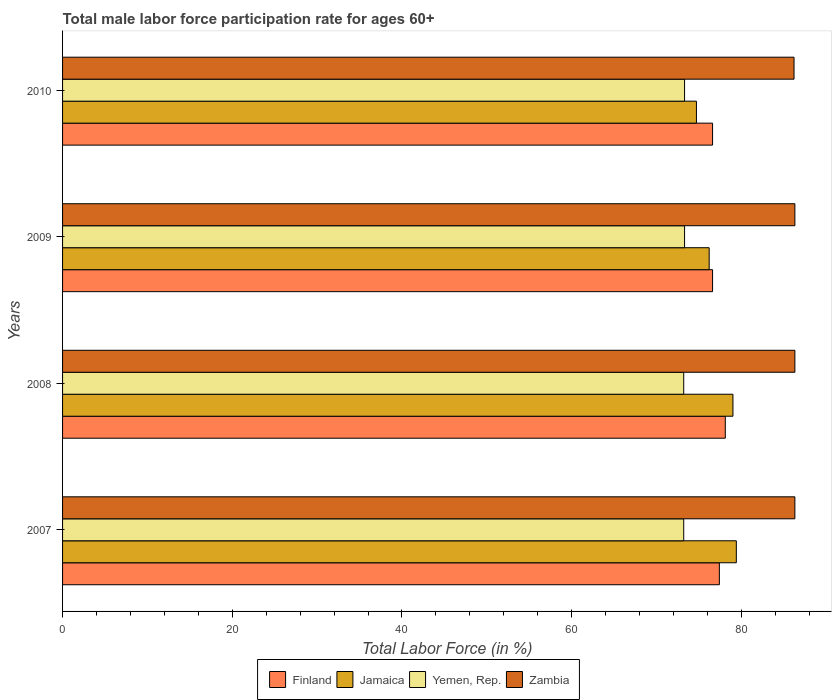How many groups of bars are there?
Offer a terse response. 4. How many bars are there on the 3rd tick from the bottom?
Provide a succinct answer. 4. In how many cases, is the number of bars for a given year not equal to the number of legend labels?
Your answer should be very brief. 0. What is the male labor force participation rate in Jamaica in 2010?
Your response must be concise. 74.7. Across all years, what is the maximum male labor force participation rate in Finland?
Ensure brevity in your answer.  78.1. Across all years, what is the minimum male labor force participation rate in Finland?
Make the answer very short. 76.6. What is the total male labor force participation rate in Finland in the graph?
Ensure brevity in your answer.  308.7. What is the difference between the male labor force participation rate in Jamaica in 2010 and the male labor force participation rate in Zambia in 2008?
Provide a succinct answer. -11.6. What is the average male labor force participation rate in Finland per year?
Provide a succinct answer. 77.17. In the year 2008, what is the difference between the male labor force participation rate in Finland and male labor force participation rate in Zambia?
Make the answer very short. -8.2. In how many years, is the male labor force participation rate in Jamaica greater than 80 %?
Provide a short and direct response. 0. What is the ratio of the male labor force participation rate in Finland in 2007 to that in 2009?
Provide a succinct answer. 1.01. Is the male labor force participation rate in Zambia in 2009 less than that in 2010?
Offer a terse response. No. What is the difference between the highest and the second highest male labor force participation rate in Zambia?
Your answer should be compact. 0. What is the difference between the highest and the lowest male labor force participation rate in Yemen, Rep.?
Make the answer very short. 0.1. Is the sum of the male labor force participation rate in Finland in 2008 and 2009 greater than the maximum male labor force participation rate in Jamaica across all years?
Keep it short and to the point. Yes. What does the 4th bar from the top in 2009 represents?
Your response must be concise. Finland. What does the 4th bar from the bottom in 2009 represents?
Make the answer very short. Zambia. How many bars are there?
Keep it short and to the point. 16. Are all the bars in the graph horizontal?
Provide a succinct answer. Yes. Does the graph contain any zero values?
Your response must be concise. No. What is the title of the graph?
Provide a succinct answer. Total male labor force participation rate for ages 60+. Does "Kuwait" appear as one of the legend labels in the graph?
Make the answer very short. No. What is the label or title of the Y-axis?
Offer a terse response. Years. What is the Total Labor Force (in %) in Finland in 2007?
Your response must be concise. 77.4. What is the Total Labor Force (in %) of Jamaica in 2007?
Your answer should be very brief. 79.4. What is the Total Labor Force (in %) in Yemen, Rep. in 2007?
Keep it short and to the point. 73.2. What is the Total Labor Force (in %) in Zambia in 2007?
Give a very brief answer. 86.3. What is the Total Labor Force (in %) of Finland in 2008?
Ensure brevity in your answer.  78.1. What is the Total Labor Force (in %) of Jamaica in 2008?
Make the answer very short. 79. What is the Total Labor Force (in %) in Yemen, Rep. in 2008?
Give a very brief answer. 73.2. What is the Total Labor Force (in %) in Zambia in 2008?
Offer a very short reply. 86.3. What is the Total Labor Force (in %) of Finland in 2009?
Offer a very short reply. 76.6. What is the Total Labor Force (in %) of Jamaica in 2009?
Give a very brief answer. 76.2. What is the Total Labor Force (in %) in Yemen, Rep. in 2009?
Make the answer very short. 73.3. What is the Total Labor Force (in %) of Zambia in 2009?
Your answer should be very brief. 86.3. What is the Total Labor Force (in %) of Finland in 2010?
Provide a short and direct response. 76.6. What is the Total Labor Force (in %) of Jamaica in 2010?
Keep it short and to the point. 74.7. What is the Total Labor Force (in %) of Yemen, Rep. in 2010?
Offer a very short reply. 73.3. What is the Total Labor Force (in %) of Zambia in 2010?
Your answer should be very brief. 86.2. Across all years, what is the maximum Total Labor Force (in %) in Finland?
Ensure brevity in your answer.  78.1. Across all years, what is the maximum Total Labor Force (in %) in Jamaica?
Ensure brevity in your answer.  79.4. Across all years, what is the maximum Total Labor Force (in %) of Yemen, Rep.?
Make the answer very short. 73.3. Across all years, what is the maximum Total Labor Force (in %) in Zambia?
Your answer should be very brief. 86.3. Across all years, what is the minimum Total Labor Force (in %) in Finland?
Give a very brief answer. 76.6. Across all years, what is the minimum Total Labor Force (in %) of Jamaica?
Your answer should be compact. 74.7. Across all years, what is the minimum Total Labor Force (in %) of Yemen, Rep.?
Give a very brief answer. 73.2. Across all years, what is the minimum Total Labor Force (in %) in Zambia?
Ensure brevity in your answer.  86.2. What is the total Total Labor Force (in %) in Finland in the graph?
Your answer should be very brief. 308.7. What is the total Total Labor Force (in %) of Jamaica in the graph?
Give a very brief answer. 309.3. What is the total Total Labor Force (in %) in Yemen, Rep. in the graph?
Ensure brevity in your answer.  293. What is the total Total Labor Force (in %) in Zambia in the graph?
Give a very brief answer. 345.1. What is the difference between the Total Labor Force (in %) in Jamaica in 2007 and that in 2008?
Your answer should be compact. 0.4. What is the difference between the Total Labor Force (in %) in Jamaica in 2007 and that in 2009?
Your answer should be compact. 3.2. What is the difference between the Total Labor Force (in %) in Zambia in 2007 and that in 2009?
Provide a short and direct response. 0. What is the difference between the Total Labor Force (in %) of Jamaica in 2007 and that in 2010?
Provide a short and direct response. 4.7. What is the difference between the Total Labor Force (in %) in Yemen, Rep. in 2007 and that in 2010?
Ensure brevity in your answer.  -0.1. What is the difference between the Total Labor Force (in %) in Finland in 2008 and that in 2009?
Provide a succinct answer. 1.5. What is the difference between the Total Labor Force (in %) in Finland in 2008 and that in 2010?
Ensure brevity in your answer.  1.5. What is the difference between the Total Labor Force (in %) in Finland in 2009 and that in 2010?
Provide a succinct answer. 0. What is the difference between the Total Labor Force (in %) of Finland in 2007 and the Total Labor Force (in %) of Jamaica in 2009?
Make the answer very short. 1.2. What is the difference between the Total Labor Force (in %) of Jamaica in 2007 and the Total Labor Force (in %) of Yemen, Rep. in 2009?
Make the answer very short. 6.1. What is the difference between the Total Labor Force (in %) in Finland in 2007 and the Total Labor Force (in %) in Jamaica in 2010?
Your answer should be compact. 2.7. What is the difference between the Total Labor Force (in %) in Yemen, Rep. in 2007 and the Total Labor Force (in %) in Zambia in 2010?
Ensure brevity in your answer.  -13. What is the difference between the Total Labor Force (in %) in Finland in 2008 and the Total Labor Force (in %) in Jamaica in 2009?
Provide a succinct answer. 1.9. What is the difference between the Total Labor Force (in %) in Finland in 2008 and the Total Labor Force (in %) in Yemen, Rep. in 2009?
Your answer should be compact. 4.8. What is the difference between the Total Labor Force (in %) of Finland in 2008 and the Total Labor Force (in %) of Zambia in 2009?
Offer a very short reply. -8.2. What is the difference between the Total Labor Force (in %) of Jamaica in 2008 and the Total Labor Force (in %) of Yemen, Rep. in 2009?
Your answer should be very brief. 5.7. What is the difference between the Total Labor Force (in %) of Jamaica in 2008 and the Total Labor Force (in %) of Zambia in 2009?
Provide a succinct answer. -7.3. What is the difference between the Total Labor Force (in %) in Yemen, Rep. in 2008 and the Total Labor Force (in %) in Zambia in 2009?
Ensure brevity in your answer.  -13.1. What is the difference between the Total Labor Force (in %) of Finland in 2008 and the Total Labor Force (in %) of Yemen, Rep. in 2010?
Give a very brief answer. 4.8. What is the difference between the Total Labor Force (in %) of Finland in 2008 and the Total Labor Force (in %) of Zambia in 2010?
Your answer should be compact. -8.1. What is the difference between the Total Labor Force (in %) of Jamaica in 2008 and the Total Labor Force (in %) of Zambia in 2010?
Provide a short and direct response. -7.2. What is the difference between the Total Labor Force (in %) of Yemen, Rep. in 2008 and the Total Labor Force (in %) of Zambia in 2010?
Provide a short and direct response. -13. What is the difference between the Total Labor Force (in %) in Finland in 2009 and the Total Labor Force (in %) in Jamaica in 2010?
Your answer should be very brief. 1.9. What is the difference between the Total Labor Force (in %) in Finland in 2009 and the Total Labor Force (in %) in Yemen, Rep. in 2010?
Make the answer very short. 3.3. What is the difference between the Total Labor Force (in %) of Yemen, Rep. in 2009 and the Total Labor Force (in %) of Zambia in 2010?
Give a very brief answer. -12.9. What is the average Total Labor Force (in %) of Finland per year?
Your answer should be compact. 77.17. What is the average Total Labor Force (in %) of Jamaica per year?
Offer a terse response. 77.33. What is the average Total Labor Force (in %) of Yemen, Rep. per year?
Offer a very short reply. 73.25. What is the average Total Labor Force (in %) in Zambia per year?
Your answer should be compact. 86.28. In the year 2007, what is the difference between the Total Labor Force (in %) in Finland and Total Labor Force (in %) in Jamaica?
Give a very brief answer. -2. In the year 2007, what is the difference between the Total Labor Force (in %) in Finland and Total Labor Force (in %) in Yemen, Rep.?
Your answer should be very brief. 4.2. In the year 2007, what is the difference between the Total Labor Force (in %) of Finland and Total Labor Force (in %) of Zambia?
Give a very brief answer. -8.9. In the year 2007, what is the difference between the Total Labor Force (in %) in Jamaica and Total Labor Force (in %) in Zambia?
Offer a very short reply. -6.9. In the year 2007, what is the difference between the Total Labor Force (in %) in Yemen, Rep. and Total Labor Force (in %) in Zambia?
Make the answer very short. -13.1. In the year 2008, what is the difference between the Total Labor Force (in %) in Finland and Total Labor Force (in %) in Jamaica?
Ensure brevity in your answer.  -0.9. In the year 2008, what is the difference between the Total Labor Force (in %) in Finland and Total Labor Force (in %) in Yemen, Rep.?
Offer a very short reply. 4.9. In the year 2008, what is the difference between the Total Labor Force (in %) of Jamaica and Total Labor Force (in %) of Yemen, Rep.?
Provide a short and direct response. 5.8. In the year 2009, what is the difference between the Total Labor Force (in %) of Finland and Total Labor Force (in %) of Yemen, Rep.?
Provide a succinct answer. 3.3. In the year 2009, what is the difference between the Total Labor Force (in %) of Jamaica and Total Labor Force (in %) of Yemen, Rep.?
Offer a very short reply. 2.9. In the year 2009, what is the difference between the Total Labor Force (in %) of Jamaica and Total Labor Force (in %) of Zambia?
Your answer should be very brief. -10.1. In the year 2010, what is the difference between the Total Labor Force (in %) of Finland and Total Labor Force (in %) of Jamaica?
Keep it short and to the point. 1.9. In the year 2010, what is the difference between the Total Labor Force (in %) in Finland and Total Labor Force (in %) in Yemen, Rep.?
Your answer should be very brief. 3.3. In the year 2010, what is the difference between the Total Labor Force (in %) of Jamaica and Total Labor Force (in %) of Zambia?
Offer a terse response. -11.5. What is the ratio of the Total Labor Force (in %) of Yemen, Rep. in 2007 to that in 2008?
Provide a short and direct response. 1. What is the ratio of the Total Labor Force (in %) of Finland in 2007 to that in 2009?
Your answer should be compact. 1.01. What is the ratio of the Total Labor Force (in %) in Jamaica in 2007 to that in 2009?
Give a very brief answer. 1.04. What is the ratio of the Total Labor Force (in %) of Zambia in 2007 to that in 2009?
Keep it short and to the point. 1. What is the ratio of the Total Labor Force (in %) of Finland in 2007 to that in 2010?
Give a very brief answer. 1.01. What is the ratio of the Total Labor Force (in %) of Jamaica in 2007 to that in 2010?
Offer a terse response. 1.06. What is the ratio of the Total Labor Force (in %) in Zambia in 2007 to that in 2010?
Offer a terse response. 1. What is the ratio of the Total Labor Force (in %) of Finland in 2008 to that in 2009?
Your response must be concise. 1.02. What is the ratio of the Total Labor Force (in %) in Jamaica in 2008 to that in 2009?
Provide a short and direct response. 1.04. What is the ratio of the Total Labor Force (in %) of Yemen, Rep. in 2008 to that in 2009?
Make the answer very short. 1. What is the ratio of the Total Labor Force (in %) in Finland in 2008 to that in 2010?
Provide a short and direct response. 1.02. What is the ratio of the Total Labor Force (in %) of Jamaica in 2008 to that in 2010?
Your answer should be compact. 1.06. What is the ratio of the Total Labor Force (in %) in Yemen, Rep. in 2008 to that in 2010?
Make the answer very short. 1. What is the ratio of the Total Labor Force (in %) of Finland in 2009 to that in 2010?
Provide a succinct answer. 1. What is the ratio of the Total Labor Force (in %) in Jamaica in 2009 to that in 2010?
Offer a terse response. 1.02. What is the ratio of the Total Labor Force (in %) of Zambia in 2009 to that in 2010?
Provide a short and direct response. 1. What is the difference between the highest and the second highest Total Labor Force (in %) of Jamaica?
Your answer should be compact. 0.4. What is the difference between the highest and the second highest Total Labor Force (in %) in Yemen, Rep.?
Keep it short and to the point. 0. What is the difference between the highest and the lowest Total Labor Force (in %) in Finland?
Offer a terse response. 1.5. What is the difference between the highest and the lowest Total Labor Force (in %) of Yemen, Rep.?
Offer a terse response. 0.1. What is the difference between the highest and the lowest Total Labor Force (in %) in Zambia?
Your answer should be very brief. 0.1. 